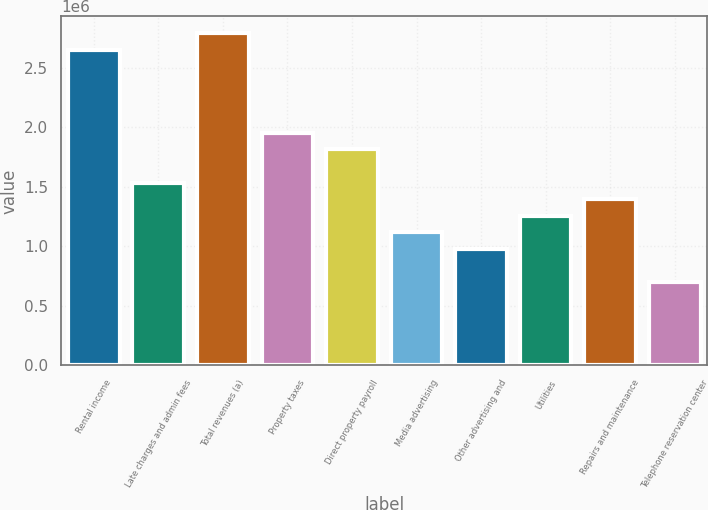<chart> <loc_0><loc_0><loc_500><loc_500><bar_chart><fcel>Rental income<fcel>Late charges and admin fees<fcel>Total revenues (a)<fcel>Property taxes<fcel>Direct property payroll<fcel>Media advertising<fcel>Other advertising and<fcel>Utilities<fcel>Repairs and maintenance<fcel>Telephone reservation center<nl><fcel>2.65383e+06<fcel>1.53643e+06<fcel>2.7935e+06<fcel>1.95546e+06<fcel>1.81578e+06<fcel>1.11741e+06<fcel>977734<fcel>1.25708e+06<fcel>1.39676e+06<fcel>698385<nl></chart> 